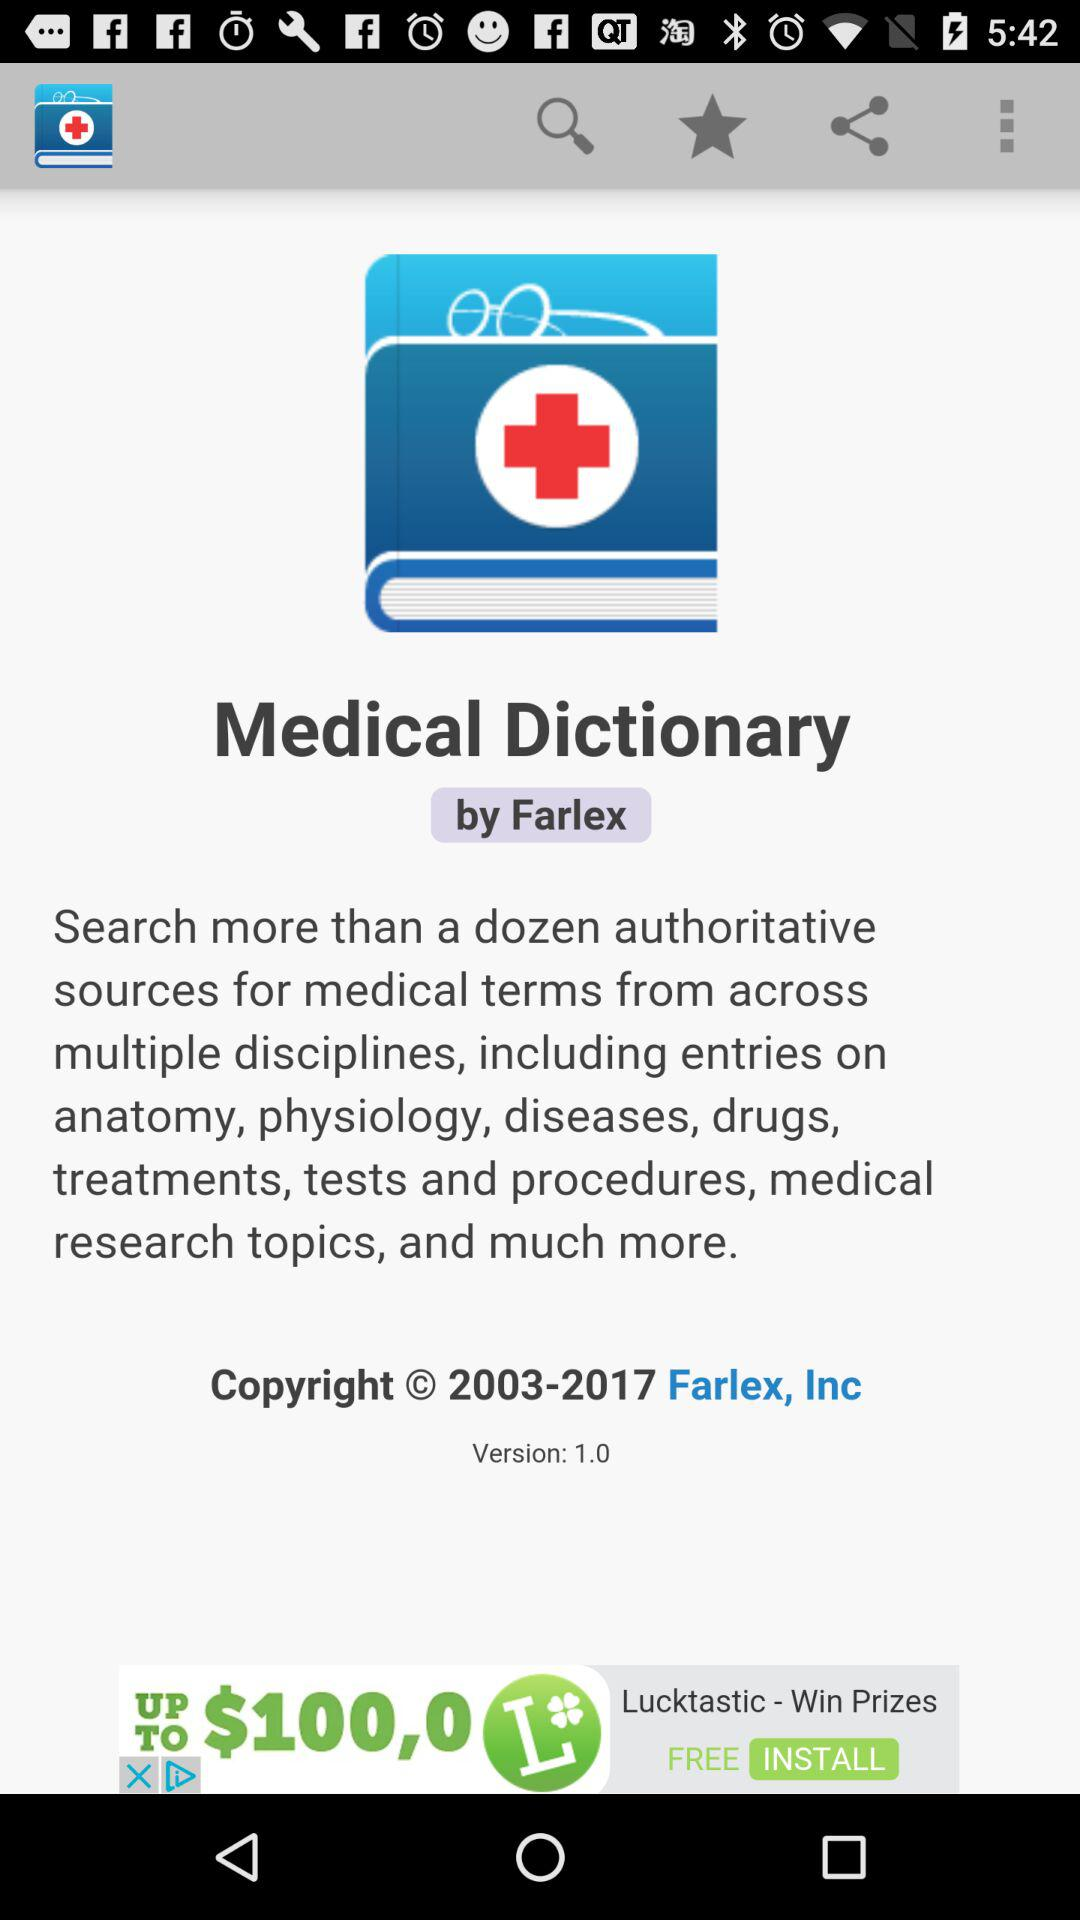What is the app name? The app name is "Medical Dictionary". 